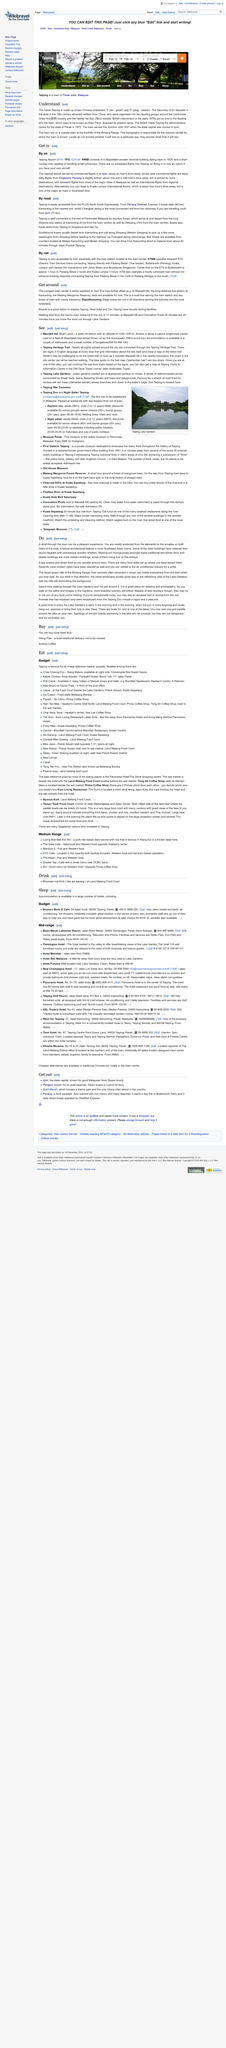Mention a couple of crucial points in this snapshot. The drive from Kamunting directly to Selama Town through Jalan Pondok Tanjung takes approximately 40 minutes, according to the information provided. The local bus company is named RapidKamuting. The local bus service operating in and around the train station has an hourly frequency. The walking time from the town's main entrance to the zoo is 17 minutes. Tickets for Southbound buses departing from Kamunting can be obtained from two locations: Medan Kamunting and Medan Simpang. 